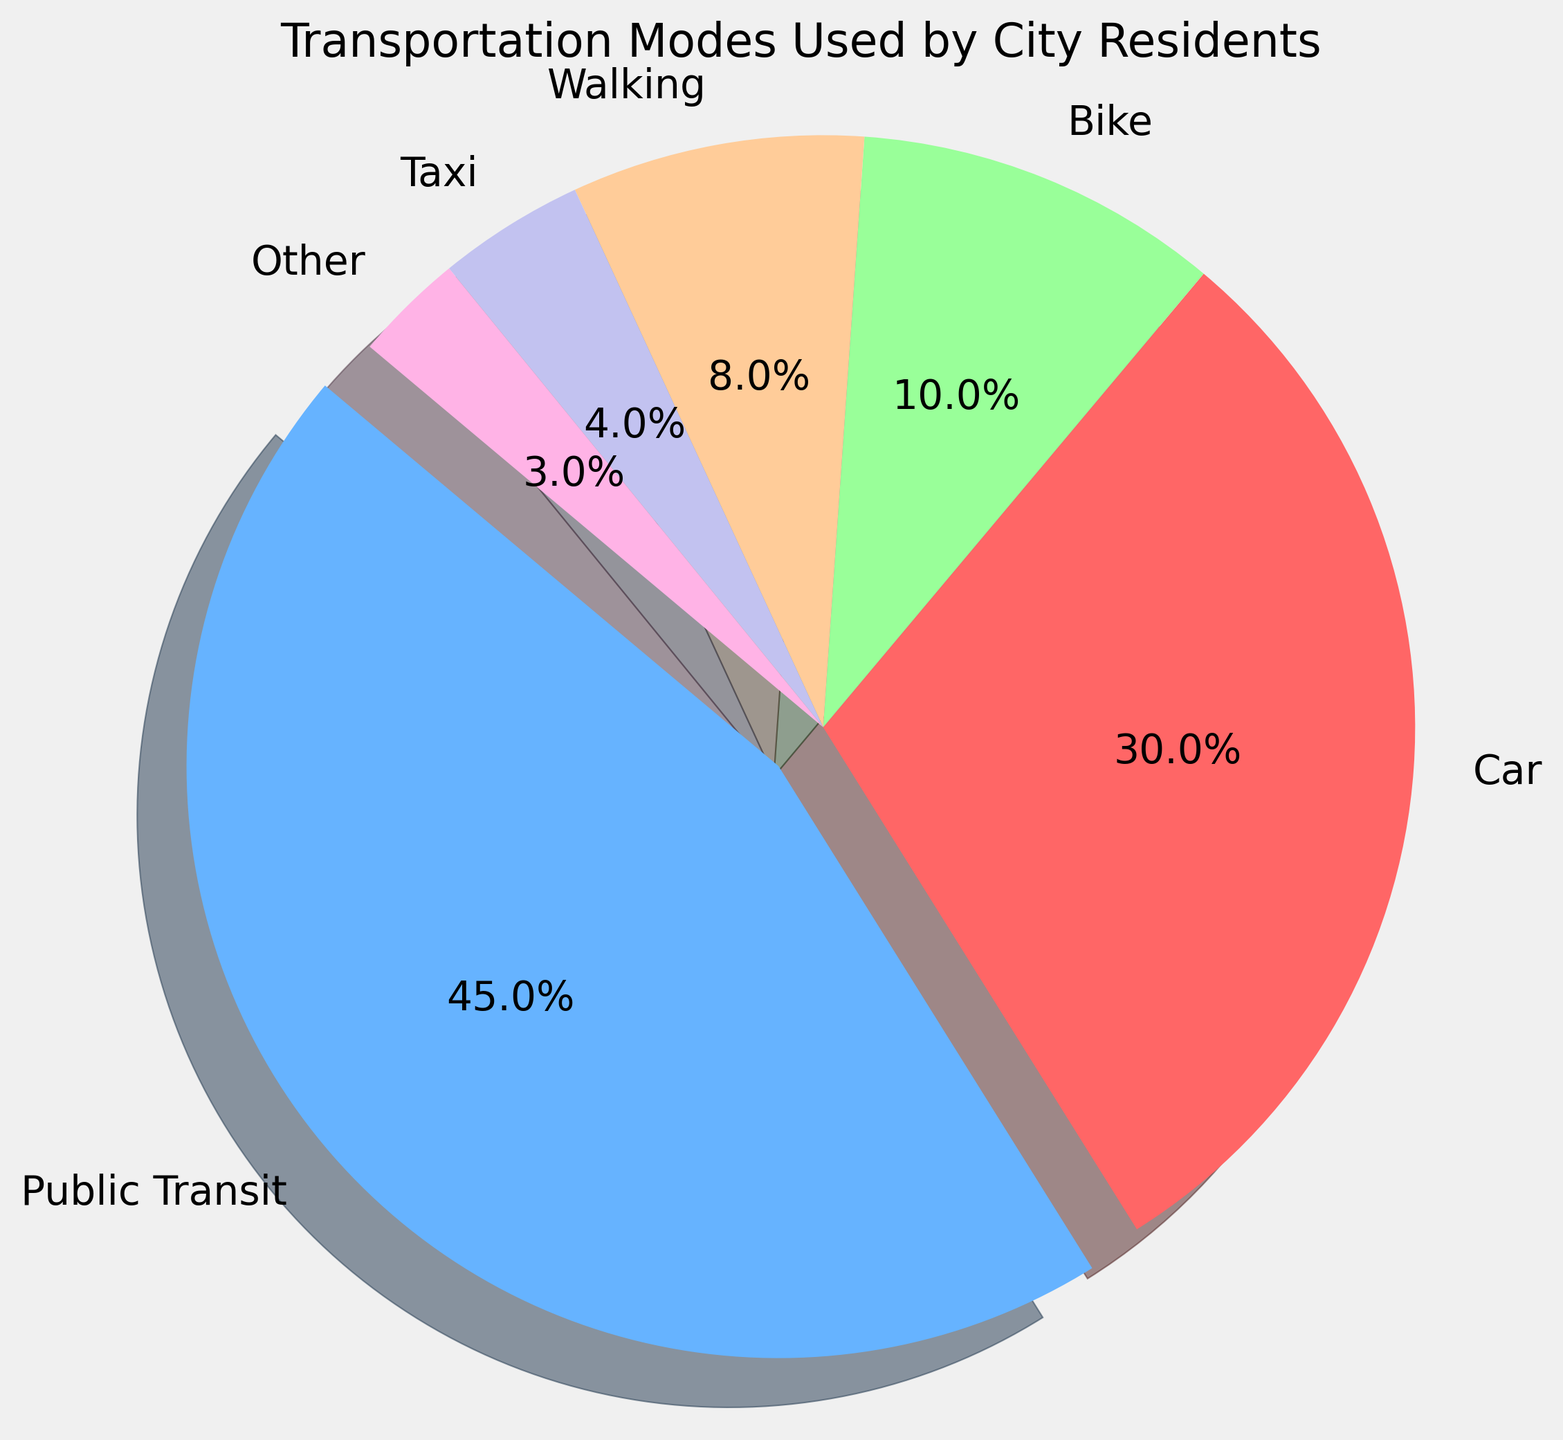What's the total percentage of residents who use Car and Taxi combined? Add the percentage of residents who use Car (30%) and Taxi (4%). The total is 30% + 4% = 34%.
Answer: 34% Which mode of transportation is the most popular among city residents? Visually identify the largest slice in the pie chart, which corresponds to Public Transit.
Answer: Public Transit How much more popular is Public Transit compared to Biking? Subtract the percentage of residents using Bike (10%) from those using Public Transit (45%). The difference is 45% - 10% = 35%.
Answer: 35% Are there more residents who prefer walking over those who prefer Taxi? Compare the percentage of residents using Walking (8%) with those using Taxi (4%). Since 8% > 4%, more residents prefer Walking.
Answer: Yes Which mode of transportation has the smallest percentage of use? Identify the smallest slice in the pie chart, which corresponds to Other (3%).
Answer: Other What is the combined percentage of residents using non-motorized transportation modes (Bike and Walking)? Add the percentage of residents using Bike (10%) and Walking (8%). The total is 10% + 8% = 18%.
Answer: 18% Describe the visual attribute of the slice representing the Car mode compared to the Public Transit mode. The Car slice is smaller and not exploded, whereas the Public Transit slice is larger and slightly exploded.
Answer: Smaller and not exploded How many times larger is the Public Transit slice compared to the Taxi slice? Divide the percentage of residents using Public Transit (45%) by those using Taxi (4%). The ratio is 45% / 4% = 11.25.
Answer: 11.25 What percentage of residents use modes of transportation other than Public Transit and Car? Subtract the sum of Public Transit (45%) and Car (30%) from 100%. The remainder is 100% - (45% + 30%) = 25%.
Answer: 25% If a new mode of transportation was introduced and used by 5% of residents, how would this affect the current percentages? Each mode's percentage would decrease as the total percentage needs to still sum to 100%. For example, Public Transit would become (45 / 105) * 100 ≈ 42.9%.
Answer: Public Transit≈42.9%, Car≈28.6%, Bike≈9.5%, Walking≈7.6%, Taxi≈3.8%, Other≈2.9% 